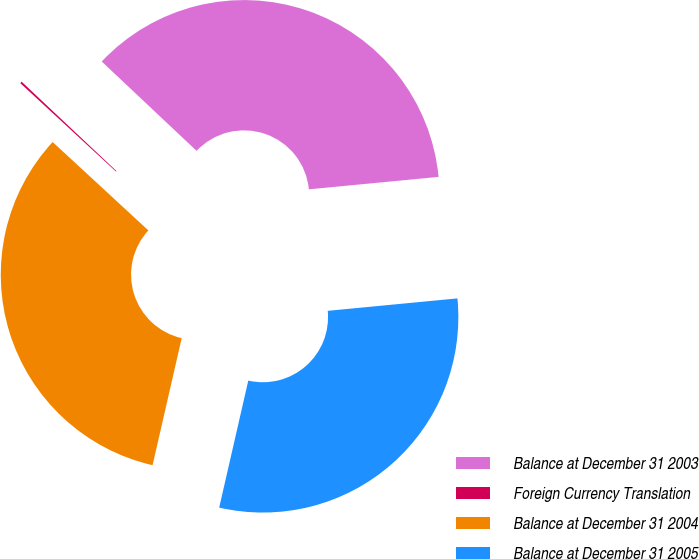Convert chart to OTSL. <chart><loc_0><loc_0><loc_500><loc_500><pie_chart><fcel>Balance at December 31 2003<fcel>Foreign Currency Translation<fcel>Balance at December 31 2004<fcel>Balance at December 31 2005<nl><fcel>36.45%<fcel>0.16%<fcel>33.28%<fcel>30.11%<nl></chart> 